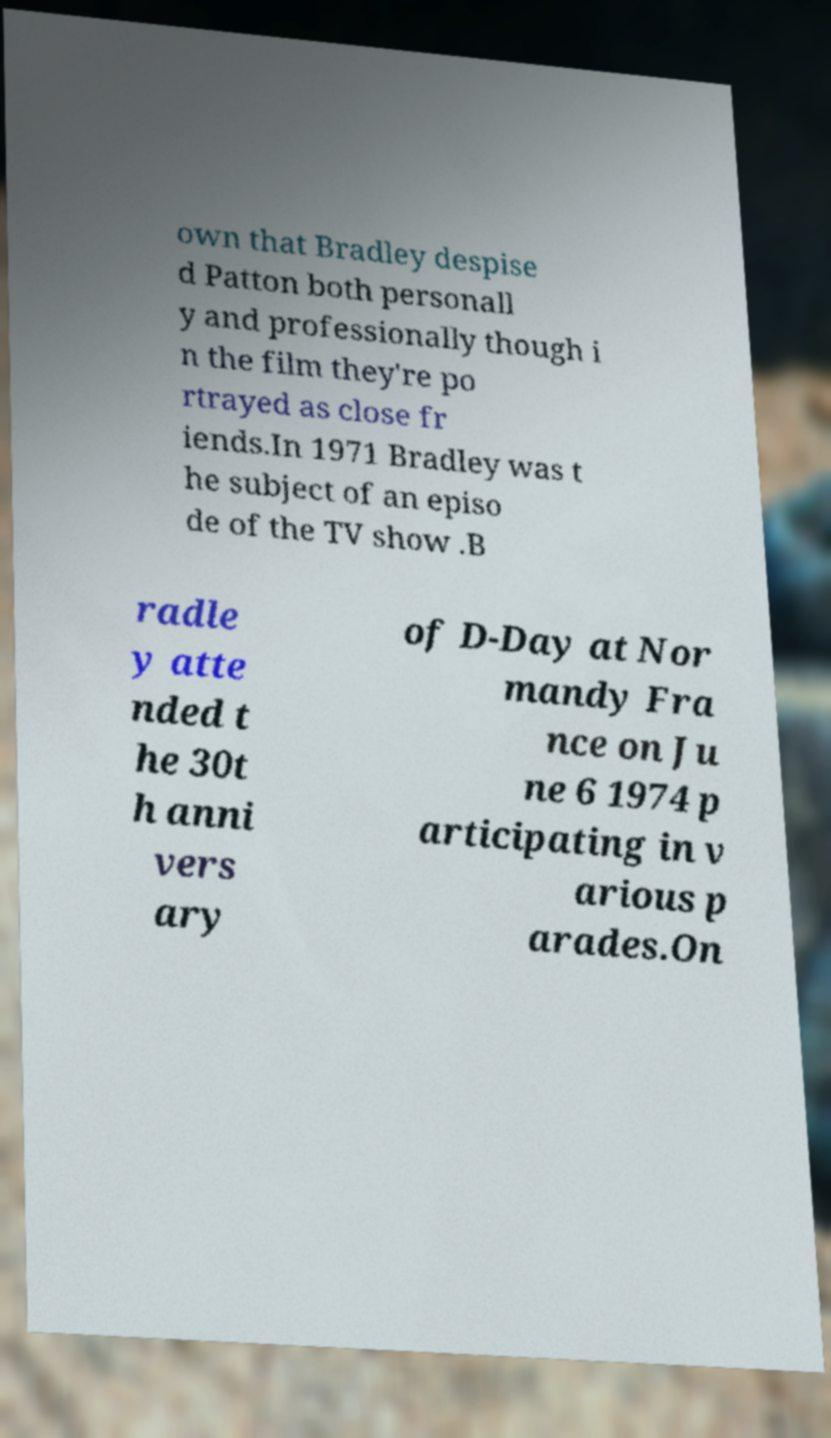For documentation purposes, I need the text within this image transcribed. Could you provide that? own that Bradley despise d Patton both personall y and professionally though i n the film they're po rtrayed as close fr iends.In 1971 Bradley was t he subject of an episo de of the TV show .B radle y atte nded t he 30t h anni vers ary of D-Day at Nor mandy Fra nce on Ju ne 6 1974 p articipating in v arious p arades.On 